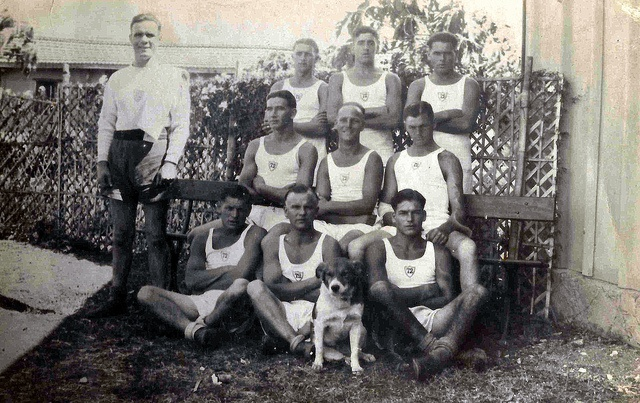Describe the objects in this image and their specific colors. I can see people in tan, black, lightgray, darkgray, and gray tones, people in tan, black, gray, darkgray, and lightgray tones, people in tan, black, gray, lightgray, and darkgray tones, bench in tan, black, gray, and darkgray tones, and people in tan, ivory, gray, darkgray, and black tones in this image. 